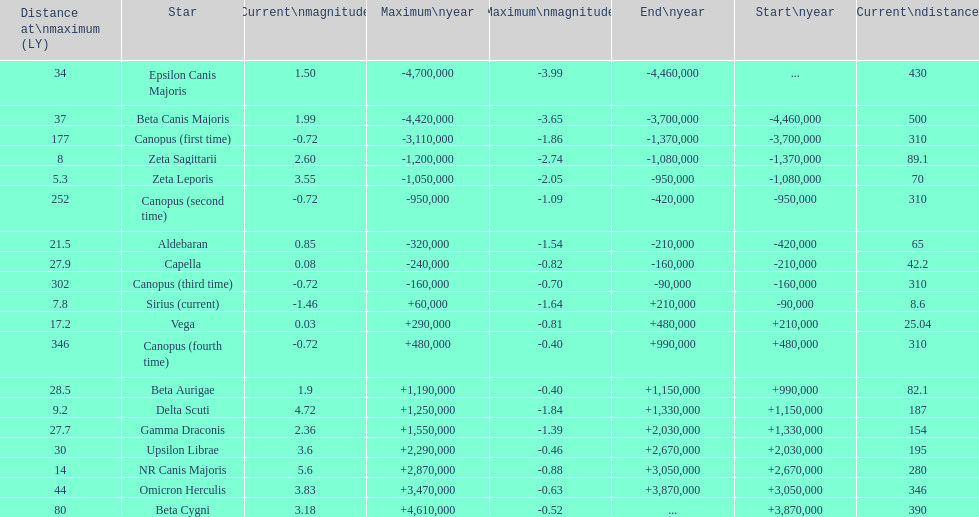Write the full table. {'header': ['Distance at\\nmaximum (LY)', 'Star', 'Current\\nmagnitude', 'Maximum\\nyear', 'Maximum\\nmagnitude', 'End\\nyear', 'Start\\nyear', 'Current\\ndistance'], 'rows': [['34', 'Epsilon Canis Majoris', '1.50', '-4,700,000', '-3.99', '-4,460,000', '...', '430'], ['37', 'Beta Canis Majoris', '1.99', '-4,420,000', '-3.65', '-3,700,000', '-4,460,000', '500'], ['177', 'Canopus (first time)', '-0.72', '-3,110,000', '-1.86', '-1,370,000', '-3,700,000', '310'], ['8', 'Zeta Sagittarii', '2.60', '-1,200,000', '-2.74', '-1,080,000', '-1,370,000', '89.1'], ['5.3', 'Zeta Leporis', '3.55', '-1,050,000', '-2.05', '-950,000', '-1,080,000', '70'], ['252', 'Canopus (second time)', '-0.72', '-950,000', '-1.09', '-420,000', '-950,000', '310'], ['21.5', 'Aldebaran', '0.85', '-320,000', '-1.54', '-210,000', '-420,000', '65'], ['27.9', 'Capella', '0.08', '-240,000', '-0.82', '-160,000', '-210,000', '42.2'], ['302', 'Canopus (third time)', '-0.72', '-160,000', '-0.70', '-90,000', '-160,000', '310'], ['7.8', 'Sirius (current)', '-1.46', '+60,000', '-1.64', '+210,000', '-90,000', '8.6'], ['17.2', 'Vega', '0.03', '+290,000', '-0.81', '+480,000', '+210,000', '25.04'], ['346', 'Canopus (fourth time)', '-0.72', '+480,000', '-0.40', '+990,000', '+480,000', '310'], ['28.5', 'Beta Aurigae', '1.9', '+1,190,000', '-0.40', '+1,150,000', '+990,000', '82.1'], ['9.2', 'Delta Scuti', '4.72', '+1,250,000', '-1.84', '+1,330,000', '+1,150,000', '187'], ['27.7', 'Gamma Draconis', '2.36', '+1,550,000', '-1.39', '+2,030,000', '+1,330,000', '154'], ['30', 'Upsilon Librae', '3.6', '+2,290,000', '-0.46', '+2,670,000', '+2,030,000', '195'], ['14', 'NR Canis Majoris', '5.6', '+2,870,000', '-0.88', '+3,050,000', '+2,670,000', '280'], ['44', 'Omicron Herculis', '3.83', '+3,470,000', '-0.63', '+3,870,000', '+3,050,000', '346'], ['80', 'Beta Cygni', '3.18', '+4,610,000', '-0.52', '...', '+3,870,000', '390']]} How many stars do not have a current magnitude greater than zero? 5. 